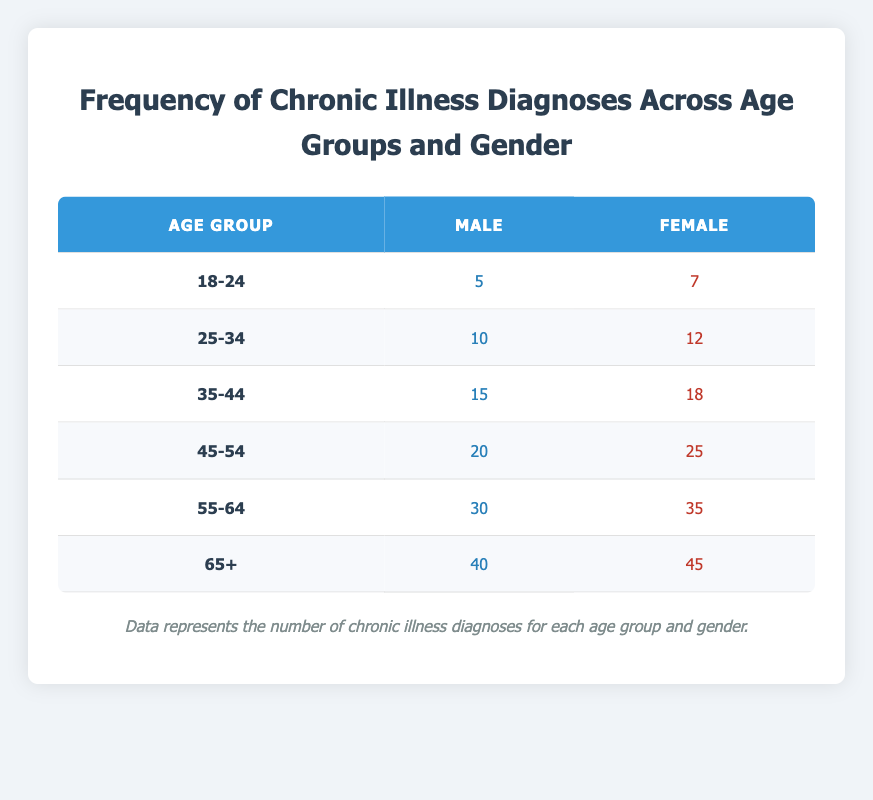What is the total number of chronic illness diagnoses for males aged 45-54? According to the table, the value for males in the age group 45-54 is 20.
Answer: 20 What is the total number of chronic illness diagnoses for females aged 55-64? According to the table, the value for females in the age group 55-64 is 35.
Answer: 35 Which gender has a higher frequency of chronic illness diagnoses in the 65+ age group? In the 65+ age group, the number for males is 40 and for females is 45. Since 45 is greater than 40, females have a higher frequency.
Answer: Female What is the combined total number of chronic illness diagnoses for all age groups for males? To find the total for males, we add the values across all age groups: 5 (18-24) + 10 (25-34) + 15 (35-44) + 20 (45-54) + 30 (55-64) + 40 (65+) = 120.
Answer: 120 What is the difference between the total chronic illness diagnoses for females in the 45-54 age group and the 25-34 age group? For females, the total for the 45-54 age group is 25 and for the 25-34 age group is 12. The difference is 25 - 12 = 13.
Answer: 13 Are there more chronic illness diagnoses for females aged 18-24 than for males in the same age group? The value for females aged 18-24 is 7, while for males it is 5. Since 7 is greater than 5, the statement is true.
Answer: Yes What is the average number of chronic illness diagnoses for males across all age groups? The total for males is 120 (calculated previously) and there are 6 age groups, so the average is 120 / 6 = 20.
Answer: 20 Which age group has the highest number of chronic illness diagnoses for females? By examining the table, the 65+ age group has the highest value for females with 45, compared to other age groups.
Answer: 65+ What proportion of chronic illness diagnoses for males is in the age group 55-64? The number of diagnoses for males in the 55-64 age group is 30, and the total for males is 120. The proportion is 30 / 120 = 0.25 or 25%.
Answer: 25% 